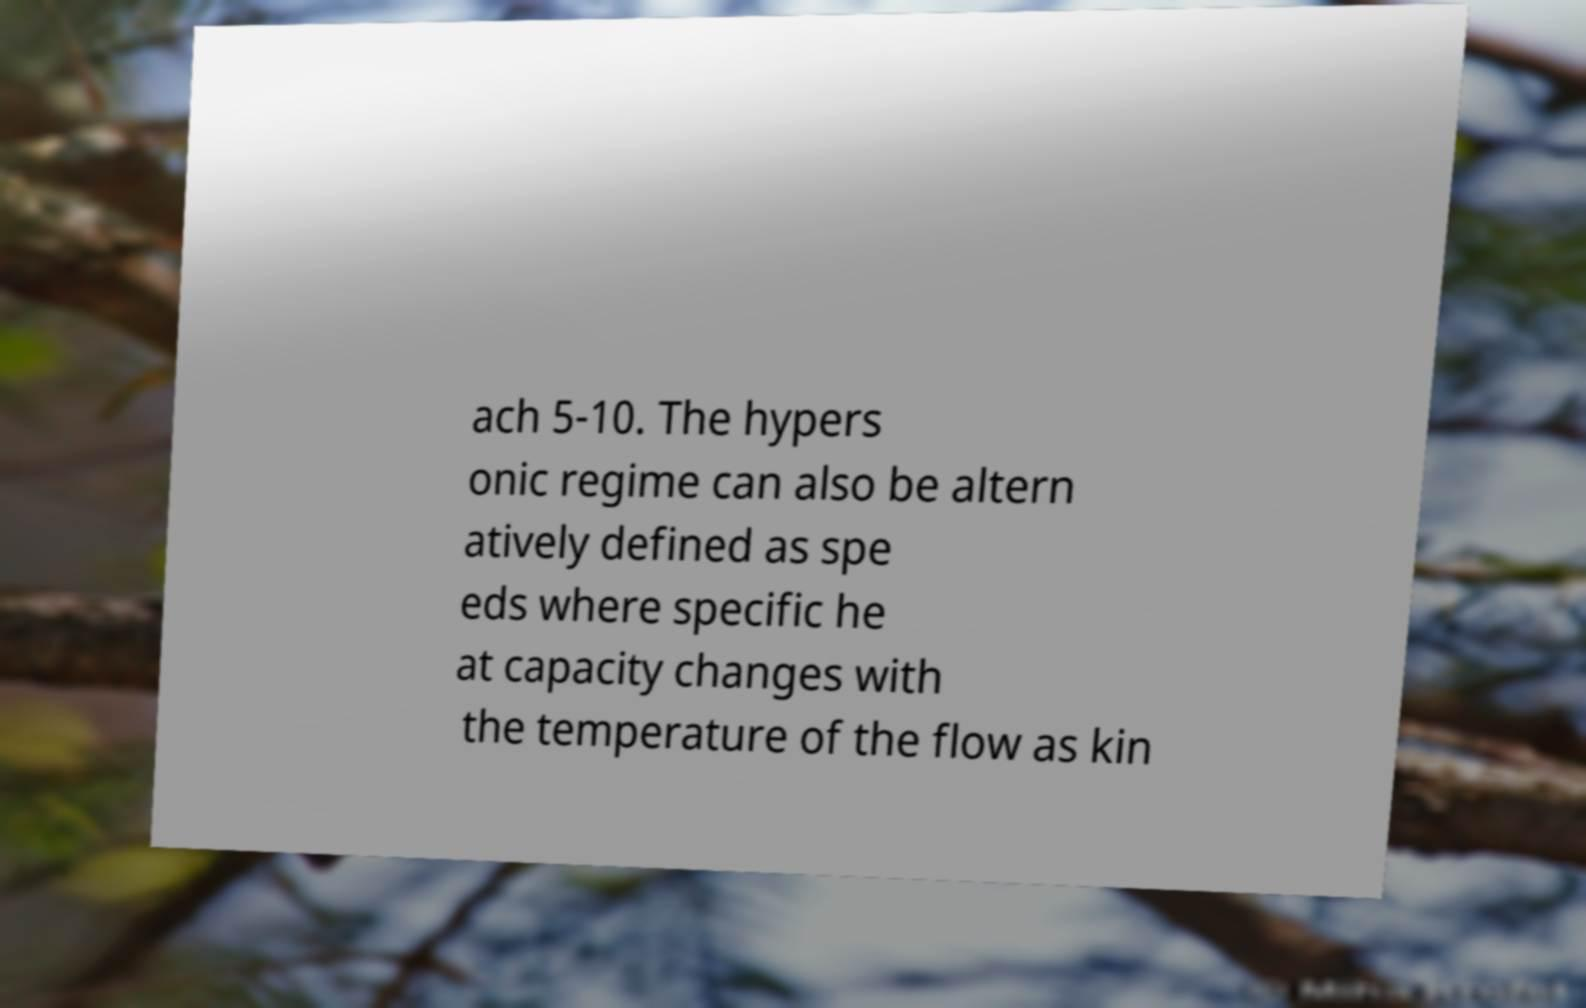Could you extract and type out the text from this image? ach 5-10. The hypers onic regime can also be altern atively defined as spe eds where specific he at capacity changes with the temperature of the flow as kin 